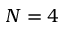<formula> <loc_0><loc_0><loc_500><loc_500>N = 4</formula> 